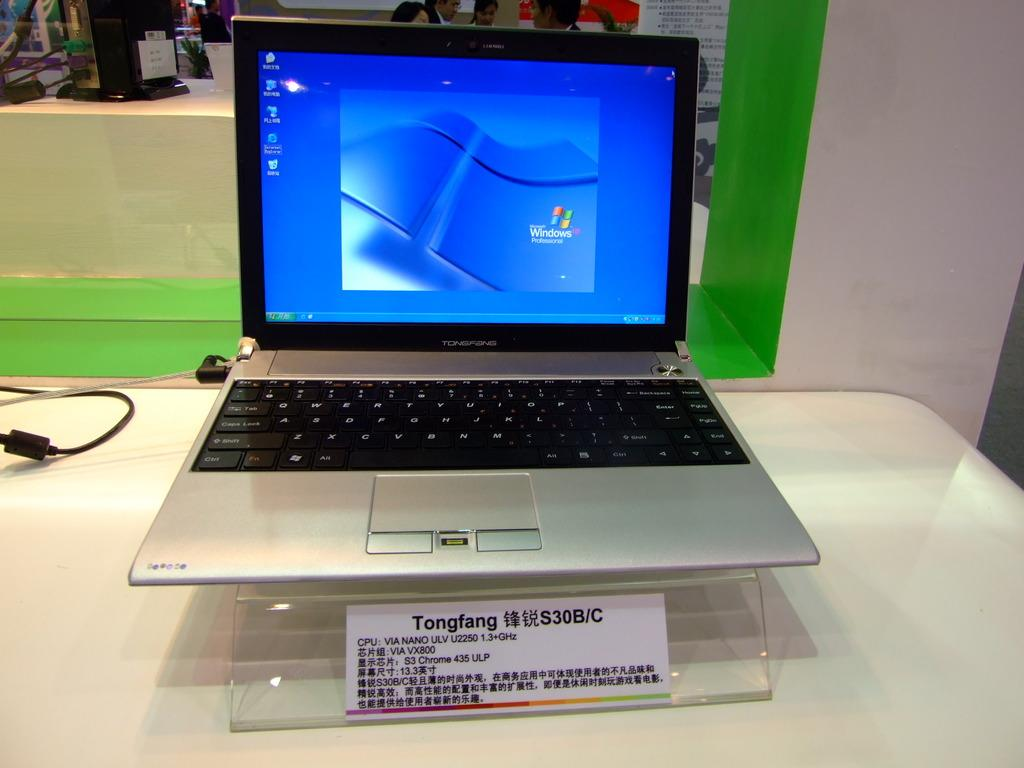<image>
Render a clear and concise summary of the photo. A computer on a clear stand has a label that says Tongfang on it. 